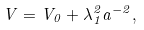<formula> <loc_0><loc_0><loc_500><loc_500>V = V _ { 0 } + \lambda _ { 1 } ^ { 2 } a ^ { - 2 } ,</formula> 